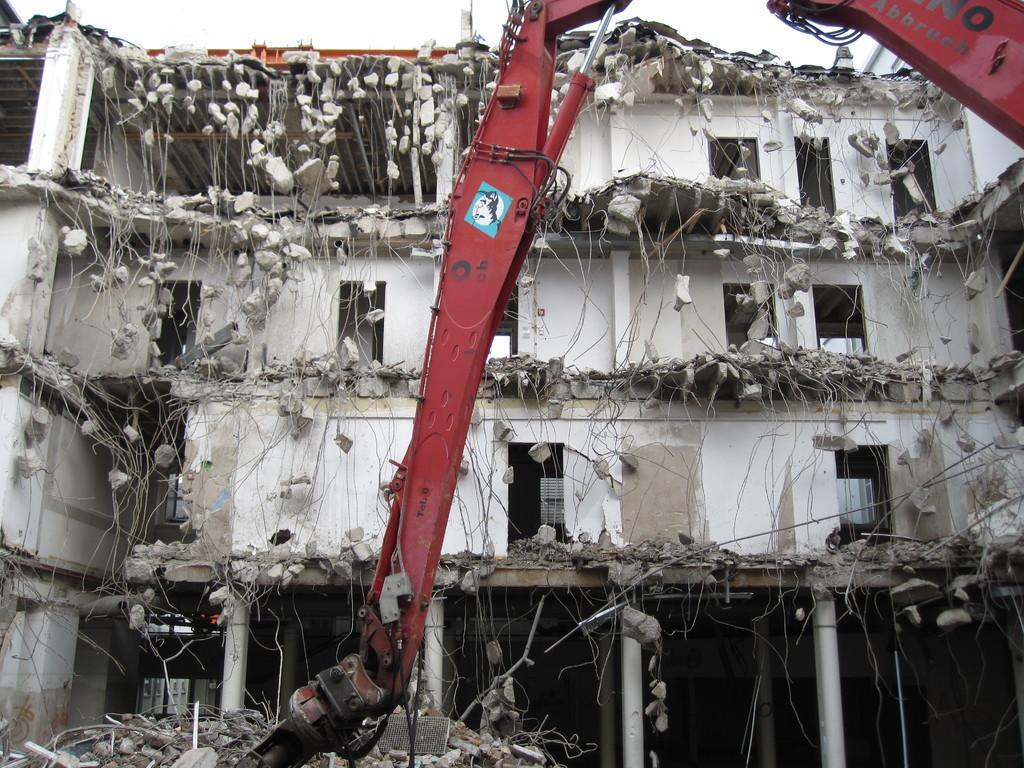Can you describe this image briefly? In this picture I can see a collapsed building. I can see a vehicle, and in the background there is the sky. 